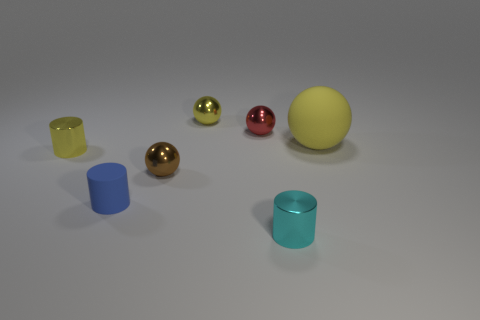What shape is the rubber thing in front of the small shiny cylinder that is left of the metallic cylinder in front of the yellow cylinder?
Your answer should be very brief. Cylinder. Is there anything else that is the same shape as the tiny brown object?
Offer a very short reply. Yes. What number of balls are either tiny brown objects or blue rubber objects?
Your response must be concise. 1. Do the tiny shiny object that is on the left side of the tiny brown thing and the big thing have the same color?
Your answer should be very brief. Yes. What is the material of the tiny thing on the left side of the rubber thing on the left side of the yellow sphere on the right side of the tiny cyan object?
Make the answer very short. Metal. Is the blue rubber cylinder the same size as the matte ball?
Give a very brief answer. No. Is the color of the big object the same as the small shiny object that is left of the brown metallic object?
Offer a very short reply. Yes. What is the shape of the red thing that is the same material as the tiny brown sphere?
Make the answer very short. Sphere. Is the shape of the yellow metallic object on the right side of the brown ball the same as  the brown shiny object?
Give a very brief answer. Yes. How big is the matte object behind the rubber object in front of the yellow metallic cylinder?
Your answer should be very brief. Large. 